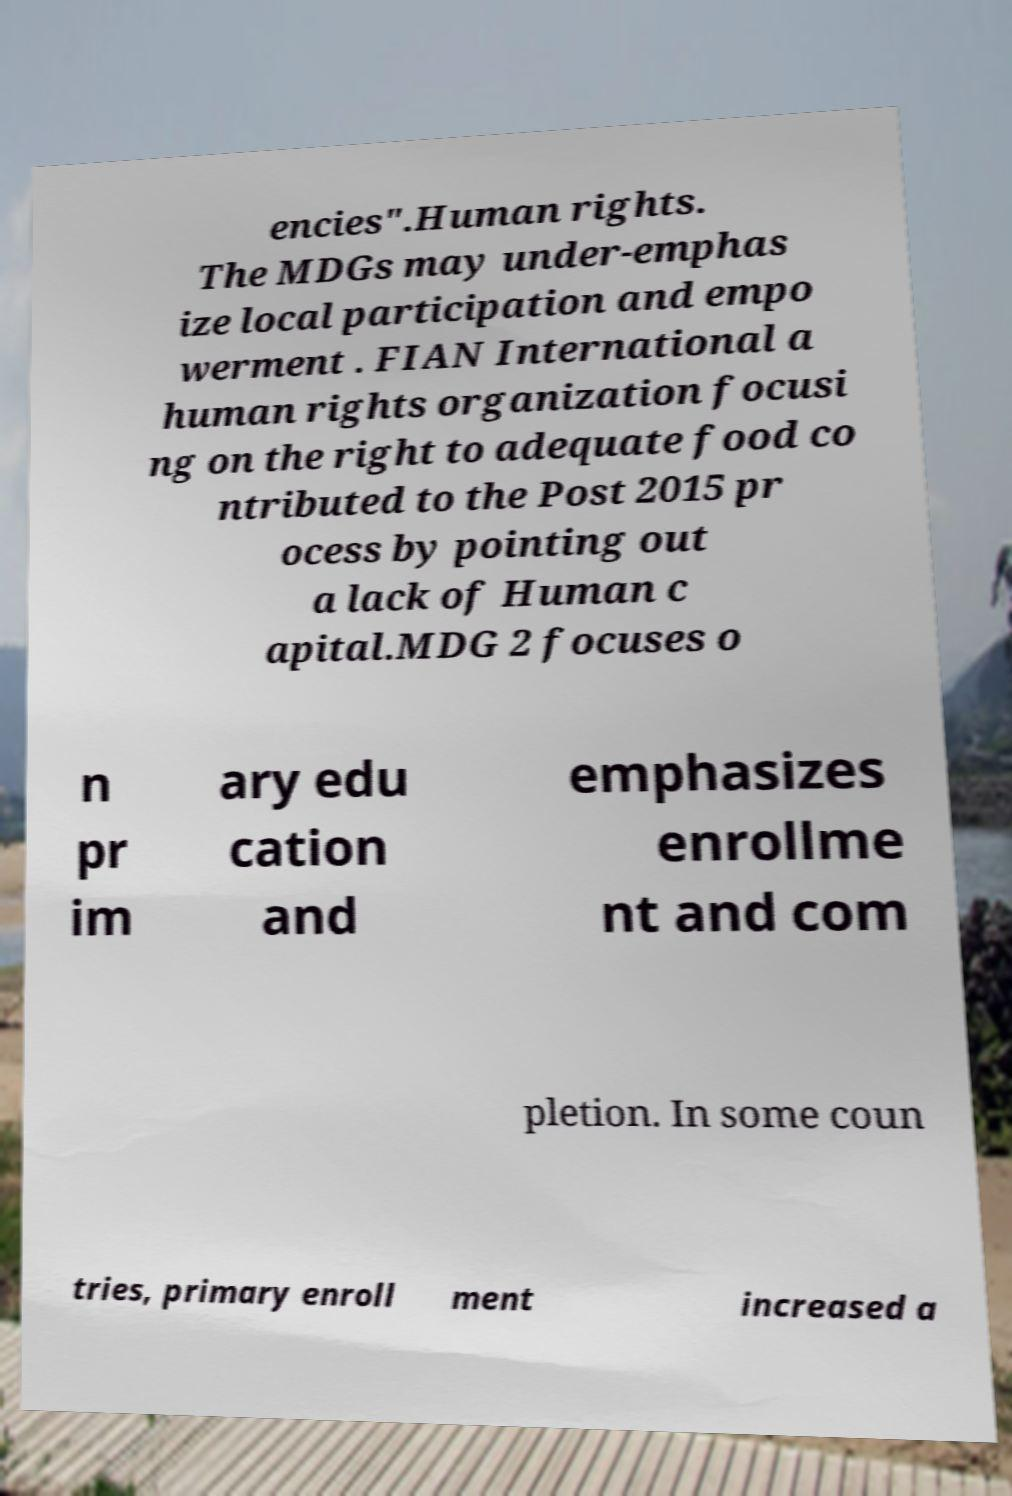I need the written content from this picture converted into text. Can you do that? encies".Human rights. The MDGs may under-emphas ize local participation and empo werment . FIAN International a human rights organization focusi ng on the right to adequate food co ntributed to the Post 2015 pr ocess by pointing out a lack of Human c apital.MDG 2 focuses o n pr im ary edu cation and emphasizes enrollme nt and com pletion. In some coun tries, primary enroll ment increased a 